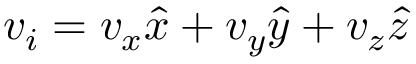<formula> <loc_0><loc_0><loc_500><loc_500>v _ { i } = v _ { x } \hat { x } + v _ { y } \hat { y } + v _ { z } \hat { z }</formula> 